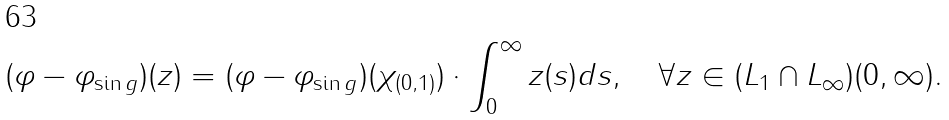<formula> <loc_0><loc_0><loc_500><loc_500>( \varphi - \varphi _ { \sin g } ) ( z ) = ( \varphi - \varphi _ { \sin g } ) ( \chi _ { ( 0 , 1 ) } ) \cdot \int _ { 0 } ^ { \infty } z ( s ) d s , \quad \forall z \in ( L _ { 1 } \cap L _ { \infty } ) ( 0 , \infty ) .</formula> 